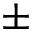<formula> <loc_0><loc_0><loc_500><loc_500>\pm</formula> 